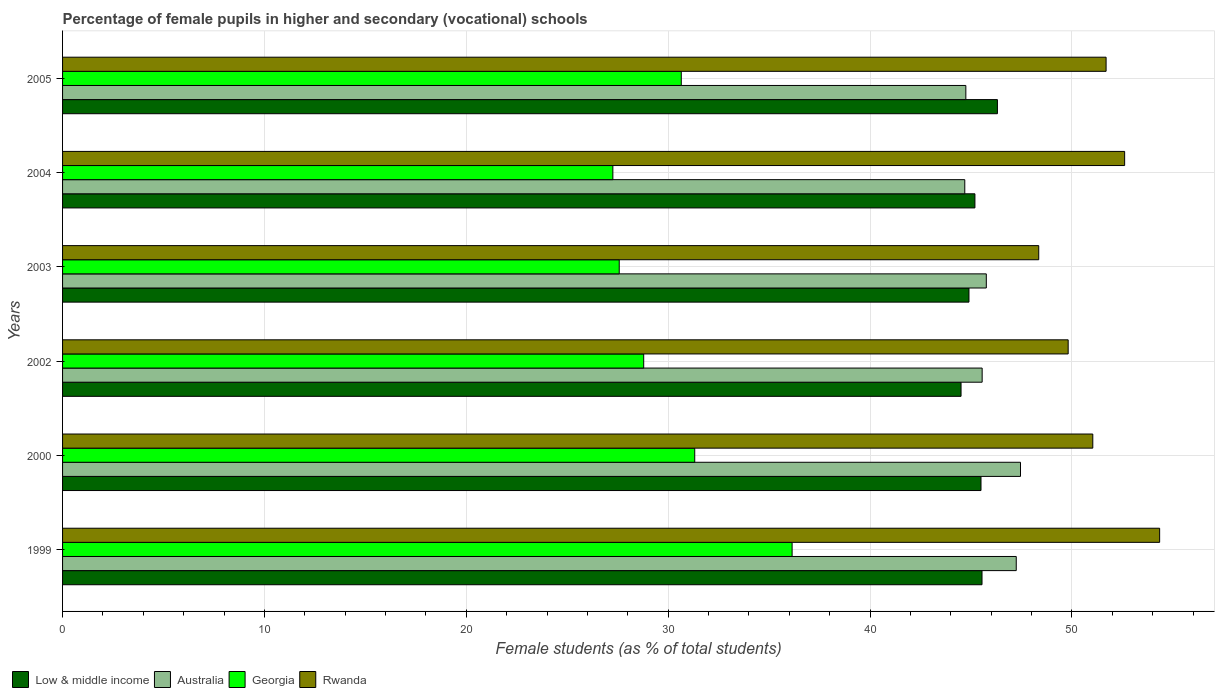How many different coloured bars are there?
Ensure brevity in your answer.  4. What is the label of the 5th group of bars from the top?
Make the answer very short. 2000. What is the percentage of female pupils in higher and secondary schools in Australia in 2005?
Your answer should be very brief. 44.74. Across all years, what is the maximum percentage of female pupils in higher and secondary schools in Low & middle income?
Make the answer very short. 46.31. Across all years, what is the minimum percentage of female pupils in higher and secondary schools in Rwanda?
Your answer should be very brief. 48.35. In which year was the percentage of female pupils in higher and secondary schools in Low & middle income maximum?
Offer a terse response. 2005. In which year was the percentage of female pupils in higher and secondary schools in Australia minimum?
Your answer should be compact. 2004. What is the total percentage of female pupils in higher and secondary schools in Rwanda in the graph?
Provide a short and direct response. 307.85. What is the difference between the percentage of female pupils in higher and secondary schools in Low & middle income in 2002 and that in 2004?
Your answer should be very brief. -0.69. What is the difference between the percentage of female pupils in higher and secondary schools in Low & middle income in 2004 and the percentage of female pupils in higher and secondary schools in Australia in 2000?
Your answer should be very brief. -2.26. What is the average percentage of female pupils in higher and secondary schools in Low & middle income per year?
Ensure brevity in your answer.  45.32. In the year 2002, what is the difference between the percentage of female pupils in higher and secondary schools in Australia and percentage of female pupils in higher and secondary schools in Rwanda?
Provide a short and direct response. -4.26. In how many years, is the percentage of female pupils in higher and secondary schools in Rwanda greater than 38 %?
Make the answer very short. 6. What is the ratio of the percentage of female pupils in higher and secondary schools in Rwanda in 1999 to that in 2004?
Keep it short and to the point. 1.03. Is the difference between the percentage of female pupils in higher and secondary schools in Australia in 2004 and 2005 greater than the difference between the percentage of female pupils in higher and secondary schools in Rwanda in 2004 and 2005?
Ensure brevity in your answer.  No. What is the difference between the highest and the second highest percentage of female pupils in higher and secondary schools in Australia?
Keep it short and to the point. 0.21. What is the difference between the highest and the lowest percentage of female pupils in higher and secondary schools in Georgia?
Your response must be concise. 8.88. Is the sum of the percentage of female pupils in higher and secondary schools in Low & middle income in 2002 and 2003 greater than the maximum percentage of female pupils in higher and secondary schools in Georgia across all years?
Your response must be concise. Yes. Is it the case that in every year, the sum of the percentage of female pupils in higher and secondary schools in Low & middle income and percentage of female pupils in higher and secondary schools in Rwanda is greater than the sum of percentage of female pupils in higher and secondary schools in Australia and percentage of female pupils in higher and secondary schools in Georgia?
Keep it short and to the point. No. What does the 4th bar from the top in 2000 represents?
Offer a terse response. Low & middle income. What does the 1st bar from the bottom in 2003 represents?
Ensure brevity in your answer.  Low & middle income. What is the difference between two consecutive major ticks on the X-axis?
Offer a very short reply. 10. Are the values on the major ticks of X-axis written in scientific E-notation?
Ensure brevity in your answer.  No. How many legend labels are there?
Your response must be concise. 4. What is the title of the graph?
Offer a terse response. Percentage of female pupils in higher and secondary (vocational) schools. Does "Guyana" appear as one of the legend labels in the graph?
Ensure brevity in your answer.  No. What is the label or title of the X-axis?
Offer a very short reply. Female students (as % of total students). What is the Female students (as % of total students) in Low & middle income in 1999?
Your response must be concise. 45.55. What is the Female students (as % of total students) of Australia in 1999?
Your response must be concise. 47.24. What is the Female students (as % of total students) in Georgia in 1999?
Your answer should be very brief. 36.14. What is the Female students (as % of total students) in Rwanda in 1999?
Offer a terse response. 54.34. What is the Female students (as % of total students) of Low & middle income in 2000?
Provide a succinct answer. 45.5. What is the Female students (as % of total students) in Australia in 2000?
Your answer should be compact. 47.45. What is the Female students (as % of total students) in Georgia in 2000?
Provide a succinct answer. 31.31. What is the Female students (as % of total students) in Rwanda in 2000?
Your answer should be compact. 51.03. What is the Female students (as % of total students) of Low & middle income in 2002?
Your response must be concise. 44.51. What is the Female students (as % of total students) in Australia in 2002?
Offer a terse response. 45.55. What is the Female students (as % of total students) in Georgia in 2002?
Give a very brief answer. 28.79. What is the Female students (as % of total students) in Rwanda in 2002?
Keep it short and to the point. 49.81. What is the Female students (as % of total students) of Low & middle income in 2003?
Ensure brevity in your answer.  44.9. What is the Female students (as % of total students) in Australia in 2003?
Give a very brief answer. 45.76. What is the Female students (as % of total students) of Georgia in 2003?
Keep it short and to the point. 27.57. What is the Female students (as % of total students) of Rwanda in 2003?
Your answer should be very brief. 48.35. What is the Female students (as % of total students) of Low & middle income in 2004?
Offer a terse response. 45.19. What is the Female students (as % of total students) of Australia in 2004?
Provide a succinct answer. 44.69. What is the Female students (as % of total students) of Georgia in 2004?
Provide a succinct answer. 27.26. What is the Female students (as % of total students) of Rwanda in 2004?
Provide a short and direct response. 52.61. What is the Female students (as % of total students) of Low & middle income in 2005?
Ensure brevity in your answer.  46.31. What is the Female students (as % of total students) of Australia in 2005?
Keep it short and to the point. 44.74. What is the Female students (as % of total students) in Georgia in 2005?
Keep it short and to the point. 30.65. What is the Female students (as % of total students) in Rwanda in 2005?
Provide a short and direct response. 51.69. Across all years, what is the maximum Female students (as % of total students) in Low & middle income?
Your response must be concise. 46.31. Across all years, what is the maximum Female students (as % of total students) of Australia?
Your response must be concise. 47.45. Across all years, what is the maximum Female students (as % of total students) in Georgia?
Your answer should be compact. 36.14. Across all years, what is the maximum Female students (as % of total students) in Rwanda?
Provide a succinct answer. 54.34. Across all years, what is the minimum Female students (as % of total students) in Low & middle income?
Your answer should be compact. 44.51. Across all years, what is the minimum Female students (as % of total students) in Australia?
Ensure brevity in your answer.  44.69. Across all years, what is the minimum Female students (as % of total students) in Georgia?
Keep it short and to the point. 27.26. Across all years, what is the minimum Female students (as % of total students) of Rwanda?
Offer a very short reply. 48.35. What is the total Female students (as % of total students) of Low & middle income in the graph?
Keep it short and to the point. 271.95. What is the total Female students (as % of total students) in Australia in the graph?
Give a very brief answer. 275.44. What is the total Female students (as % of total students) in Georgia in the graph?
Provide a short and direct response. 181.72. What is the total Female students (as % of total students) of Rwanda in the graph?
Make the answer very short. 307.85. What is the difference between the Female students (as % of total students) in Low & middle income in 1999 and that in 2000?
Provide a short and direct response. 0.05. What is the difference between the Female students (as % of total students) of Australia in 1999 and that in 2000?
Make the answer very short. -0.21. What is the difference between the Female students (as % of total students) of Georgia in 1999 and that in 2000?
Your response must be concise. 4.82. What is the difference between the Female students (as % of total students) in Rwanda in 1999 and that in 2000?
Your answer should be compact. 3.31. What is the difference between the Female students (as % of total students) of Low & middle income in 1999 and that in 2002?
Make the answer very short. 1.04. What is the difference between the Female students (as % of total students) of Australia in 1999 and that in 2002?
Ensure brevity in your answer.  1.69. What is the difference between the Female students (as % of total students) in Georgia in 1999 and that in 2002?
Provide a short and direct response. 7.35. What is the difference between the Female students (as % of total students) of Rwanda in 1999 and that in 2002?
Offer a terse response. 4.53. What is the difference between the Female students (as % of total students) in Low & middle income in 1999 and that in 2003?
Your response must be concise. 0.65. What is the difference between the Female students (as % of total students) in Australia in 1999 and that in 2003?
Your answer should be very brief. 1.48. What is the difference between the Female students (as % of total students) in Georgia in 1999 and that in 2003?
Provide a succinct answer. 8.56. What is the difference between the Female students (as % of total students) in Rwanda in 1999 and that in 2003?
Your response must be concise. 5.99. What is the difference between the Female students (as % of total students) of Low & middle income in 1999 and that in 2004?
Provide a succinct answer. 0.35. What is the difference between the Female students (as % of total students) in Australia in 1999 and that in 2004?
Your answer should be very brief. 2.55. What is the difference between the Female students (as % of total students) in Georgia in 1999 and that in 2004?
Provide a short and direct response. 8.88. What is the difference between the Female students (as % of total students) of Rwanda in 1999 and that in 2004?
Offer a very short reply. 1.73. What is the difference between the Female students (as % of total students) in Low & middle income in 1999 and that in 2005?
Provide a succinct answer. -0.76. What is the difference between the Female students (as % of total students) of Australia in 1999 and that in 2005?
Offer a very short reply. 2.5. What is the difference between the Female students (as % of total students) of Georgia in 1999 and that in 2005?
Keep it short and to the point. 5.49. What is the difference between the Female students (as % of total students) of Rwanda in 1999 and that in 2005?
Ensure brevity in your answer.  2.65. What is the difference between the Female students (as % of total students) in Low & middle income in 2000 and that in 2002?
Ensure brevity in your answer.  0.99. What is the difference between the Female students (as % of total students) in Australia in 2000 and that in 2002?
Make the answer very short. 1.9. What is the difference between the Female students (as % of total students) in Georgia in 2000 and that in 2002?
Provide a succinct answer. 2.53. What is the difference between the Female students (as % of total students) of Rwanda in 2000 and that in 2002?
Provide a short and direct response. 1.22. What is the difference between the Female students (as % of total students) of Low & middle income in 2000 and that in 2003?
Make the answer very short. 0.6. What is the difference between the Female students (as % of total students) of Australia in 2000 and that in 2003?
Provide a succinct answer. 1.69. What is the difference between the Female students (as % of total students) in Georgia in 2000 and that in 2003?
Give a very brief answer. 3.74. What is the difference between the Female students (as % of total students) in Rwanda in 2000 and that in 2003?
Your answer should be very brief. 2.68. What is the difference between the Female students (as % of total students) in Low & middle income in 2000 and that in 2004?
Offer a very short reply. 0.3. What is the difference between the Female students (as % of total students) in Australia in 2000 and that in 2004?
Keep it short and to the point. 2.76. What is the difference between the Female students (as % of total students) of Georgia in 2000 and that in 2004?
Your answer should be compact. 4.06. What is the difference between the Female students (as % of total students) of Rwanda in 2000 and that in 2004?
Make the answer very short. -1.58. What is the difference between the Female students (as % of total students) in Low & middle income in 2000 and that in 2005?
Give a very brief answer. -0.81. What is the difference between the Female students (as % of total students) of Australia in 2000 and that in 2005?
Make the answer very short. 2.71. What is the difference between the Female students (as % of total students) in Georgia in 2000 and that in 2005?
Your response must be concise. 0.67. What is the difference between the Female students (as % of total students) of Rwanda in 2000 and that in 2005?
Give a very brief answer. -0.66. What is the difference between the Female students (as % of total students) in Low & middle income in 2002 and that in 2003?
Give a very brief answer. -0.39. What is the difference between the Female students (as % of total students) in Australia in 2002 and that in 2003?
Provide a short and direct response. -0.21. What is the difference between the Female students (as % of total students) in Georgia in 2002 and that in 2003?
Your response must be concise. 1.21. What is the difference between the Female students (as % of total students) of Rwanda in 2002 and that in 2003?
Ensure brevity in your answer.  1.46. What is the difference between the Female students (as % of total students) in Low & middle income in 2002 and that in 2004?
Give a very brief answer. -0.69. What is the difference between the Female students (as % of total students) in Australia in 2002 and that in 2004?
Ensure brevity in your answer.  0.86. What is the difference between the Female students (as % of total students) of Georgia in 2002 and that in 2004?
Your answer should be compact. 1.53. What is the difference between the Female students (as % of total students) in Rwanda in 2002 and that in 2004?
Offer a very short reply. -2.8. What is the difference between the Female students (as % of total students) in Low & middle income in 2002 and that in 2005?
Provide a short and direct response. -1.8. What is the difference between the Female students (as % of total students) of Australia in 2002 and that in 2005?
Your answer should be compact. 0.81. What is the difference between the Female students (as % of total students) in Georgia in 2002 and that in 2005?
Make the answer very short. -1.86. What is the difference between the Female students (as % of total students) in Rwanda in 2002 and that in 2005?
Give a very brief answer. -1.88. What is the difference between the Female students (as % of total students) in Low & middle income in 2003 and that in 2004?
Offer a very short reply. -0.29. What is the difference between the Female students (as % of total students) in Australia in 2003 and that in 2004?
Your response must be concise. 1.07. What is the difference between the Female students (as % of total students) of Georgia in 2003 and that in 2004?
Give a very brief answer. 0.32. What is the difference between the Female students (as % of total students) in Rwanda in 2003 and that in 2004?
Offer a terse response. -4.26. What is the difference between the Female students (as % of total students) of Low & middle income in 2003 and that in 2005?
Your response must be concise. -1.41. What is the difference between the Female students (as % of total students) of Australia in 2003 and that in 2005?
Offer a terse response. 1.01. What is the difference between the Female students (as % of total students) of Georgia in 2003 and that in 2005?
Provide a short and direct response. -3.07. What is the difference between the Female students (as % of total students) of Rwanda in 2003 and that in 2005?
Offer a terse response. -3.34. What is the difference between the Female students (as % of total students) in Low & middle income in 2004 and that in 2005?
Make the answer very short. -1.11. What is the difference between the Female students (as % of total students) in Australia in 2004 and that in 2005?
Make the answer very short. -0.05. What is the difference between the Female students (as % of total students) in Georgia in 2004 and that in 2005?
Offer a terse response. -3.39. What is the difference between the Female students (as % of total students) in Rwanda in 2004 and that in 2005?
Ensure brevity in your answer.  0.92. What is the difference between the Female students (as % of total students) in Low & middle income in 1999 and the Female students (as % of total students) in Australia in 2000?
Offer a very short reply. -1.91. What is the difference between the Female students (as % of total students) of Low & middle income in 1999 and the Female students (as % of total students) of Georgia in 2000?
Make the answer very short. 14.23. What is the difference between the Female students (as % of total students) in Low & middle income in 1999 and the Female students (as % of total students) in Rwanda in 2000?
Your answer should be very brief. -5.49. What is the difference between the Female students (as % of total students) of Australia in 1999 and the Female students (as % of total students) of Georgia in 2000?
Make the answer very short. 15.93. What is the difference between the Female students (as % of total students) of Australia in 1999 and the Female students (as % of total students) of Rwanda in 2000?
Give a very brief answer. -3.79. What is the difference between the Female students (as % of total students) in Georgia in 1999 and the Female students (as % of total students) in Rwanda in 2000?
Your answer should be very brief. -14.89. What is the difference between the Female students (as % of total students) of Low & middle income in 1999 and the Female students (as % of total students) of Australia in 2002?
Your answer should be very brief. -0.01. What is the difference between the Female students (as % of total students) in Low & middle income in 1999 and the Female students (as % of total students) in Georgia in 2002?
Provide a short and direct response. 16.76. What is the difference between the Female students (as % of total students) in Low & middle income in 1999 and the Female students (as % of total students) in Rwanda in 2002?
Provide a short and direct response. -4.27. What is the difference between the Female students (as % of total students) in Australia in 1999 and the Female students (as % of total students) in Georgia in 2002?
Keep it short and to the point. 18.45. What is the difference between the Female students (as % of total students) in Australia in 1999 and the Female students (as % of total students) in Rwanda in 2002?
Provide a short and direct response. -2.57. What is the difference between the Female students (as % of total students) of Georgia in 1999 and the Female students (as % of total students) of Rwanda in 2002?
Ensure brevity in your answer.  -13.68. What is the difference between the Female students (as % of total students) in Low & middle income in 1999 and the Female students (as % of total students) in Australia in 2003?
Your answer should be very brief. -0.21. What is the difference between the Female students (as % of total students) of Low & middle income in 1999 and the Female students (as % of total students) of Georgia in 2003?
Your response must be concise. 17.97. What is the difference between the Female students (as % of total students) of Low & middle income in 1999 and the Female students (as % of total students) of Rwanda in 2003?
Keep it short and to the point. -2.81. What is the difference between the Female students (as % of total students) in Australia in 1999 and the Female students (as % of total students) in Georgia in 2003?
Keep it short and to the point. 19.67. What is the difference between the Female students (as % of total students) of Australia in 1999 and the Female students (as % of total students) of Rwanda in 2003?
Give a very brief answer. -1.11. What is the difference between the Female students (as % of total students) in Georgia in 1999 and the Female students (as % of total students) in Rwanda in 2003?
Offer a very short reply. -12.22. What is the difference between the Female students (as % of total students) of Low & middle income in 1999 and the Female students (as % of total students) of Australia in 2004?
Your answer should be compact. 0.85. What is the difference between the Female students (as % of total students) of Low & middle income in 1999 and the Female students (as % of total students) of Georgia in 2004?
Provide a short and direct response. 18.29. What is the difference between the Female students (as % of total students) of Low & middle income in 1999 and the Female students (as % of total students) of Rwanda in 2004?
Offer a terse response. -7.07. What is the difference between the Female students (as % of total students) of Australia in 1999 and the Female students (as % of total students) of Georgia in 2004?
Offer a terse response. 19.98. What is the difference between the Female students (as % of total students) in Australia in 1999 and the Female students (as % of total students) in Rwanda in 2004?
Offer a very short reply. -5.37. What is the difference between the Female students (as % of total students) in Georgia in 1999 and the Female students (as % of total students) in Rwanda in 2004?
Offer a very short reply. -16.47. What is the difference between the Female students (as % of total students) of Low & middle income in 1999 and the Female students (as % of total students) of Australia in 2005?
Give a very brief answer. 0.8. What is the difference between the Female students (as % of total students) of Low & middle income in 1999 and the Female students (as % of total students) of Georgia in 2005?
Your answer should be very brief. 14.9. What is the difference between the Female students (as % of total students) in Low & middle income in 1999 and the Female students (as % of total students) in Rwanda in 2005?
Ensure brevity in your answer.  -6.15. What is the difference between the Female students (as % of total students) in Australia in 1999 and the Female students (as % of total students) in Georgia in 2005?
Your answer should be compact. 16.59. What is the difference between the Female students (as % of total students) in Australia in 1999 and the Female students (as % of total students) in Rwanda in 2005?
Your answer should be compact. -4.45. What is the difference between the Female students (as % of total students) of Georgia in 1999 and the Female students (as % of total students) of Rwanda in 2005?
Your answer should be very brief. -15.55. What is the difference between the Female students (as % of total students) in Low & middle income in 2000 and the Female students (as % of total students) in Australia in 2002?
Keep it short and to the point. -0.06. What is the difference between the Female students (as % of total students) in Low & middle income in 2000 and the Female students (as % of total students) in Georgia in 2002?
Provide a short and direct response. 16.71. What is the difference between the Female students (as % of total students) of Low & middle income in 2000 and the Female students (as % of total students) of Rwanda in 2002?
Provide a short and direct response. -4.32. What is the difference between the Female students (as % of total students) in Australia in 2000 and the Female students (as % of total students) in Georgia in 2002?
Provide a succinct answer. 18.66. What is the difference between the Female students (as % of total students) in Australia in 2000 and the Female students (as % of total students) in Rwanda in 2002?
Your response must be concise. -2.36. What is the difference between the Female students (as % of total students) of Georgia in 2000 and the Female students (as % of total students) of Rwanda in 2002?
Your answer should be compact. -18.5. What is the difference between the Female students (as % of total students) of Low & middle income in 2000 and the Female students (as % of total students) of Australia in 2003?
Offer a very short reply. -0.26. What is the difference between the Female students (as % of total students) of Low & middle income in 2000 and the Female students (as % of total students) of Georgia in 2003?
Ensure brevity in your answer.  17.92. What is the difference between the Female students (as % of total students) of Low & middle income in 2000 and the Female students (as % of total students) of Rwanda in 2003?
Ensure brevity in your answer.  -2.86. What is the difference between the Female students (as % of total students) of Australia in 2000 and the Female students (as % of total students) of Georgia in 2003?
Keep it short and to the point. 19.88. What is the difference between the Female students (as % of total students) of Australia in 2000 and the Female students (as % of total students) of Rwanda in 2003?
Offer a very short reply. -0.9. What is the difference between the Female students (as % of total students) of Georgia in 2000 and the Female students (as % of total students) of Rwanda in 2003?
Your answer should be very brief. -17.04. What is the difference between the Female students (as % of total students) in Low & middle income in 2000 and the Female students (as % of total students) in Australia in 2004?
Provide a succinct answer. 0.8. What is the difference between the Female students (as % of total students) in Low & middle income in 2000 and the Female students (as % of total students) in Georgia in 2004?
Offer a very short reply. 18.24. What is the difference between the Female students (as % of total students) in Low & middle income in 2000 and the Female students (as % of total students) in Rwanda in 2004?
Ensure brevity in your answer.  -7.11. What is the difference between the Female students (as % of total students) of Australia in 2000 and the Female students (as % of total students) of Georgia in 2004?
Provide a succinct answer. 20.19. What is the difference between the Female students (as % of total students) of Australia in 2000 and the Female students (as % of total students) of Rwanda in 2004?
Provide a short and direct response. -5.16. What is the difference between the Female students (as % of total students) in Georgia in 2000 and the Female students (as % of total students) in Rwanda in 2004?
Offer a very short reply. -21.3. What is the difference between the Female students (as % of total students) in Low & middle income in 2000 and the Female students (as % of total students) in Australia in 2005?
Offer a terse response. 0.75. What is the difference between the Female students (as % of total students) of Low & middle income in 2000 and the Female students (as % of total students) of Georgia in 2005?
Your response must be concise. 14.85. What is the difference between the Female students (as % of total students) in Low & middle income in 2000 and the Female students (as % of total students) in Rwanda in 2005?
Provide a succinct answer. -6.2. What is the difference between the Female students (as % of total students) of Australia in 2000 and the Female students (as % of total students) of Georgia in 2005?
Your answer should be very brief. 16.8. What is the difference between the Female students (as % of total students) of Australia in 2000 and the Female students (as % of total students) of Rwanda in 2005?
Keep it short and to the point. -4.24. What is the difference between the Female students (as % of total students) in Georgia in 2000 and the Female students (as % of total students) in Rwanda in 2005?
Give a very brief answer. -20.38. What is the difference between the Female students (as % of total students) in Low & middle income in 2002 and the Female students (as % of total students) in Australia in 2003?
Make the answer very short. -1.25. What is the difference between the Female students (as % of total students) of Low & middle income in 2002 and the Female students (as % of total students) of Georgia in 2003?
Your response must be concise. 16.93. What is the difference between the Female students (as % of total students) of Low & middle income in 2002 and the Female students (as % of total students) of Rwanda in 2003?
Make the answer very short. -3.85. What is the difference between the Female students (as % of total students) of Australia in 2002 and the Female students (as % of total students) of Georgia in 2003?
Give a very brief answer. 17.98. What is the difference between the Female students (as % of total students) of Australia in 2002 and the Female students (as % of total students) of Rwanda in 2003?
Ensure brevity in your answer.  -2.8. What is the difference between the Female students (as % of total students) in Georgia in 2002 and the Female students (as % of total students) in Rwanda in 2003?
Give a very brief answer. -19.57. What is the difference between the Female students (as % of total students) of Low & middle income in 2002 and the Female students (as % of total students) of Australia in 2004?
Make the answer very short. -0.18. What is the difference between the Female students (as % of total students) of Low & middle income in 2002 and the Female students (as % of total students) of Georgia in 2004?
Your response must be concise. 17.25. What is the difference between the Female students (as % of total students) in Low & middle income in 2002 and the Female students (as % of total students) in Rwanda in 2004?
Your answer should be very brief. -8.1. What is the difference between the Female students (as % of total students) in Australia in 2002 and the Female students (as % of total students) in Georgia in 2004?
Keep it short and to the point. 18.29. What is the difference between the Female students (as % of total students) of Australia in 2002 and the Female students (as % of total students) of Rwanda in 2004?
Give a very brief answer. -7.06. What is the difference between the Female students (as % of total students) in Georgia in 2002 and the Female students (as % of total students) in Rwanda in 2004?
Give a very brief answer. -23.82. What is the difference between the Female students (as % of total students) of Low & middle income in 2002 and the Female students (as % of total students) of Australia in 2005?
Your answer should be compact. -0.24. What is the difference between the Female students (as % of total students) in Low & middle income in 2002 and the Female students (as % of total students) in Georgia in 2005?
Make the answer very short. 13.86. What is the difference between the Female students (as % of total students) in Low & middle income in 2002 and the Female students (as % of total students) in Rwanda in 2005?
Offer a very short reply. -7.18. What is the difference between the Female students (as % of total students) of Australia in 2002 and the Female students (as % of total students) of Georgia in 2005?
Keep it short and to the point. 14.9. What is the difference between the Female students (as % of total students) in Australia in 2002 and the Female students (as % of total students) in Rwanda in 2005?
Offer a very short reply. -6.14. What is the difference between the Female students (as % of total students) of Georgia in 2002 and the Female students (as % of total students) of Rwanda in 2005?
Make the answer very short. -22.9. What is the difference between the Female students (as % of total students) in Low & middle income in 2003 and the Female students (as % of total students) in Australia in 2004?
Make the answer very short. 0.21. What is the difference between the Female students (as % of total students) in Low & middle income in 2003 and the Female students (as % of total students) in Georgia in 2004?
Make the answer very short. 17.64. What is the difference between the Female students (as % of total students) of Low & middle income in 2003 and the Female students (as % of total students) of Rwanda in 2004?
Offer a terse response. -7.71. What is the difference between the Female students (as % of total students) in Australia in 2003 and the Female students (as % of total students) in Georgia in 2004?
Your answer should be compact. 18.5. What is the difference between the Female students (as % of total students) in Australia in 2003 and the Female students (as % of total students) in Rwanda in 2004?
Your answer should be compact. -6.85. What is the difference between the Female students (as % of total students) of Georgia in 2003 and the Female students (as % of total students) of Rwanda in 2004?
Provide a short and direct response. -25.04. What is the difference between the Female students (as % of total students) in Low & middle income in 2003 and the Female students (as % of total students) in Australia in 2005?
Ensure brevity in your answer.  0.15. What is the difference between the Female students (as % of total students) in Low & middle income in 2003 and the Female students (as % of total students) in Georgia in 2005?
Your answer should be very brief. 14.25. What is the difference between the Female students (as % of total students) of Low & middle income in 2003 and the Female students (as % of total students) of Rwanda in 2005?
Ensure brevity in your answer.  -6.79. What is the difference between the Female students (as % of total students) of Australia in 2003 and the Female students (as % of total students) of Georgia in 2005?
Give a very brief answer. 15.11. What is the difference between the Female students (as % of total students) in Australia in 2003 and the Female students (as % of total students) in Rwanda in 2005?
Your response must be concise. -5.93. What is the difference between the Female students (as % of total students) in Georgia in 2003 and the Female students (as % of total students) in Rwanda in 2005?
Offer a very short reply. -24.12. What is the difference between the Female students (as % of total students) of Low & middle income in 2004 and the Female students (as % of total students) of Australia in 2005?
Provide a succinct answer. 0.45. What is the difference between the Female students (as % of total students) in Low & middle income in 2004 and the Female students (as % of total students) in Georgia in 2005?
Ensure brevity in your answer.  14.55. What is the difference between the Female students (as % of total students) in Low & middle income in 2004 and the Female students (as % of total students) in Rwanda in 2005?
Ensure brevity in your answer.  -6.5. What is the difference between the Female students (as % of total students) in Australia in 2004 and the Female students (as % of total students) in Georgia in 2005?
Offer a terse response. 14.04. What is the difference between the Female students (as % of total students) in Australia in 2004 and the Female students (as % of total students) in Rwanda in 2005?
Your answer should be very brief. -7. What is the difference between the Female students (as % of total students) of Georgia in 2004 and the Female students (as % of total students) of Rwanda in 2005?
Ensure brevity in your answer.  -24.43. What is the average Female students (as % of total students) of Low & middle income per year?
Offer a very short reply. 45.32. What is the average Female students (as % of total students) in Australia per year?
Your answer should be compact. 45.91. What is the average Female students (as % of total students) of Georgia per year?
Ensure brevity in your answer.  30.29. What is the average Female students (as % of total students) of Rwanda per year?
Keep it short and to the point. 51.31. In the year 1999, what is the difference between the Female students (as % of total students) of Low & middle income and Female students (as % of total students) of Australia?
Your response must be concise. -1.7. In the year 1999, what is the difference between the Female students (as % of total students) in Low & middle income and Female students (as % of total students) in Georgia?
Ensure brevity in your answer.  9.41. In the year 1999, what is the difference between the Female students (as % of total students) of Low & middle income and Female students (as % of total students) of Rwanda?
Your answer should be compact. -8.8. In the year 1999, what is the difference between the Female students (as % of total students) in Australia and Female students (as % of total students) in Georgia?
Provide a short and direct response. 11.1. In the year 1999, what is the difference between the Female students (as % of total students) of Australia and Female students (as % of total students) of Rwanda?
Your answer should be very brief. -7.1. In the year 1999, what is the difference between the Female students (as % of total students) of Georgia and Female students (as % of total students) of Rwanda?
Offer a very short reply. -18.21. In the year 2000, what is the difference between the Female students (as % of total students) of Low & middle income and Female students (as % of total students) of Australia?
Your answer should be very brief. -1.96. In the year 2000, what is the difference between the Female students (as % of total students) in Low & middle income and Female students (as % of total students) in Georgia?
Offer a very short reply. 14.18. In the year 2000, what is the difference between the Female students (as % of total students) of Low & middle income and Female students (as % of total students) of Rwanda?
Make the answer very short. -5.54. In the year 2000, what is the difference between the Female students (as % of total students) of Australia and Female students (as % of total students) of Georgia?
Your answer should be compact. 16.14. In the year 2000, what is the difference between the Female students (as % of total students) of Australia and Female students (as % of total students) of Rwanda?
Your answer should be compact. -3.58. In the year 2000, what is the difference between the Female students (as % of total students) in Georgia and Female students (as % of total students) in Rwanda?
Your answer should be very brief. -19.72. In the year 2002, what is the difference between the Female students (as % of total students) of Low & middle income and Female students (as % of total students) of Australia?
Make the answer very short. -1.05. In the year 2002, what is the difference between the Female students (as % of total students) in Low & middle income and Female students (as % of total students) in Georgia?
Ensure brevity in your answer.  15.72. In the year 2002, what is the difference between the Female students (as % of total students) of Low & middle income and Female students (as % of total students) of Rwanda?
Offer a very short reply. -5.31. In the year 2002, what is the difference between the Female students (as % of total students) of Australia and Female students (as % of total students) of Georgia?
Make the answer very short. 16.77. In the year 2002, what is the difference between the Female students (as % of total students) of Australia and Female students (as % of total students) of Rwanda?
Provide a succinct answer. -4.26. In the year 2002, what is the difference between the Female students (as % of total students) in Georgia and Female students (as % of total students) in Rwanda?
Offer a terse response. -21.03. In the year 2003, what is the difference between the Female students (as % of total students) in Low & middle income and Female students (as % of total students) in Australia?
Offer a very short reply. -0.86. In the year 2003, what is the difference between the Female students (as % of total students) of Low & middle income and Female students (as % of total students) of Georgia?
Provide a succinct answer. 17.32. In the year 2003, what is the difference between the Female students (as % of total students) in Low & middle income and Female students (as % of total students) in Rwanda?
Your answer should be very brief. -3.46. In the year 2003, what is the difference between the Female students (as % of total students) in Australia and Female students (as % of total students) in Georgia?
Provide a short and direct response. 18.18. In the year 2003, what is the difference between the Female students (as % of total students) in Australia and Female students (as % of total students) in Rwanda?
Offer a terse response. -2.6. In the year 2003, what is the difference between the Female students (as % of total students) in Georgia and Female students (as % of total students) in Rwanda?
Keep it short and to the point. -20.78. In the year 2004, what is the difference between the Female students (as % of total students) of Low & middle income and Female students (as % of total students) of Australia?
Your answer should be compact. 0.5. In the year 2004, what is the difference between the Female students (as % of total students) in Low & middle income and Female students (as % of total students) in Georgia?
Offer a terse response. 17.93. In the year 2004, what is the difference between the Female students (as % of total students) of Low & middle income and Female students (as % of total students) of Rwanda?
Your answer should be compact. -7.42. In the year 2004, what is the difference between the Female students (as % of total students) of Australia and Female students (as % of total students) of Georgia?
Your answer should be very brief. 17.43. In the year 2004, what is the difference between the Female students (as % of total students) of Australia and Female students (as % of total students) of Rwanda?
Offer a terse response. -7.92. In the year 2004, what is the difference between the Female students (as % of total students) in Georgia and Female students (as % of total students) in Rwanda?
Provide a succinct answer. -25.35. In the year 2005, what is the difference between the Female students (as % of total students) of Low & middle income and Female students (as % of total students) of Australia?
Provide a short and direct response. 1.56. In the year 2005, what is the difference between the Female students (as % of total students) in Low & middle income and Female students (as % of total students) in Georgia?
Give a very brief answer. 15.66. In the year 2005, what is the difference between the Female students (as % of total students) in Low & middle income and Female students (as % of total students) in Rwanda?
Keep it short and to the point. -5.38. In the year 2005, what is the difference between the Female students (as % of total students) in Australia and Female students (as % of total students) in Georgia?
Keep it short and to the point. 14.1. In the year 2005, what is the difference between the Female students (as % of total students) of Australia and Female students (as % of total students) of Rwanda?
Give a very brief answer. -6.95. In the year 2005, what is the difference between the Female students (as % of total students) in Georgia and Female students (as % of total students) in Rwanda?
Your response must be concise. -21.04. What is the ratio of the Female students (as % of total students) of Low & middle income in 1999 to that in 2000?
Ensure brevity in your answer.  1. What is the ratio of the Female students (as % of total students) of Georgia in 1999 to that in 2000?
Offer a very short reply. 1.15. What is the ratio of the Female students (as % of total students) in Rwanda in 1999 to that in 2000?
Provide a short and direct response. 1.06. What is the ratio of the Female students (as % of total students) in Low & middle income in 1999 to that in 2002?
Offer a very short reply. 1.02. What is the ratio of the Female students (as % of total students) in Australia in 1999 to that in 2002?
Keep it short and to the point. 1.04. What is the ratio of the Female students (as % of total students) in Georgia in 1999 to that in 2002?
Make the answer very short. 1.26. What is the ratio of the Female students (as % of total students) in Rwanda in 1999 to that in 2002?
Provide a short and direct response. 1.09. What is the ratio of the Female students (as % of total students) in Low & middle income in 1999 to that in 2003?
Give a very brief answer. 1.01. What is the ratio of the Female students (as % of total students) of Australia in 1999 to that in 2003?
Your answer should be very brief. 1.03. What is the ratio of the Female students (as % of total students) of Georgia in 1999 to that in 2003?
Provide a succinct answer. 1.31. What is the ratio of the Female students (as % of total students) in Rwanda in 1999 to that in 2003?
Provide a succinct answer. 1.12. What is the ratio of the Female students (as % of total students) in Australia in 1999 to that in 2004?
Provide a short and direct response. 1.06. What is the ratio of the Female students (as % of total students) in Georgia in 1999 to that in 2004?
Keep it short and to the point. 1.33. What is the ratio of the Female students (as % of total students) of Rwanda in 1999 to that in 2004?
Your answer should be very brief. 1.03. What is the ratio of the Female students (as % of total students) in Low & middle income in 1999 to that in 2005?
Provide a short and direct response. 0.98. What is the ratio of the Female students (as % of total students) in Australia in 1999 to that in 2005?
Give a very brief answer. 1.06. What is the ratio of the Female students (as % of total students) of Georgia in 1999 to that in 2005?
Keep it short and to the point. 1.18. What is the ratio of the Female students (as % of total students) of Rwanda in 1999 to that in 2005?
Ensure brevity in your answer.  1.05. What is the ratio of the Female students (as % of total students) of Low & middle income in 2000 to that in 2002?
Keep it short and to the point. 1.02. What is the ratio of the Female students (as % of total students) of Australia in 2000 to that in 2002?
Offer a terse response. 1.04. What is the ratio of the Female students (as % of total students) in Georgia in 2000 to that in 2002?
Offer a terse response. 1.09. What is the ratio of the Female students (as % of total students) in Rwanda in 2000 to that in 2002?
Your answer should be very brief. 1.02. What is the ratio of the Female students (as % of total students) in Low & middle income in 2000 to that in 2003?
Your response must be concise. 1.01. What is the ratio of the Female students (as % of total students) of Georgia in 2000 to that in 2003?
Your answer should be very brief. 1.14. What is the ratio of the Female students (as % of total students) in Rwanda in 2000 to that in 2003?
Offer a very short reply. 1.06. What is the ratio of the Female students (as % of total students) of Australia in 2000 to that in 2004?
Offer a very short reply. 1.06. What is the ratio of the Female students (as % of total students) of Georgia in 2000 to that in 2004?
Give a very brief answer. 1.15. What is the ratio of the Female students (as % of total students) of Rwanda in 2000 to that in 2004?
Your answer should be compact. 0.97. What is the ratio of the Female students (as % of total students) in Low & middle income in 2000 to that in 2005?
Your response must be concise. 0.98. What is the ratio of the Female students (as % of total students) in Australia in 2000 to that in 2005?
Keep it short and to the point. 1.06. What is the ratio of the Female students (as % of total students) in Georgia in 2000 to that in 2005?
Your answer should be very brief. 1.02. What is the ratio of the Female students (as % of total students) of Rwanda in 2000 to that in 2005?
Offer a very short reply. 0.99. What is the ratio of the Female students (as % of total students) in Georgia in 2002 to that in 2003?
Make the answer very short. 1.04. What is the ratio of the Female students (as % of total students) in Rwanda in 2002 to that in 2003?
Ensure brevity in your answer.  1.03. What is the ratio of the Female students (as % of total students) of Low & middle income in 2002 to that in 2004?
Your answer should be compact. 0.98. What is the ratio of the Female students (as % of total students) of Australia in 2002 to that in 2004?
Make the answer very short. 1.02. What is the ratio of the Female students (as % of total students) of Georgia in 2002 to that in 2004?
Ensure brevity in your answer.  1.06. What is the ratio of the Female students (as % of total students) of Rwanda in 2002 to that in 2004?
Your answer should be very brief. 0.95. What is the ratio of the Female students (as % of total students) in Low & middle income in 2002 to that in 2005?
Your answer should be compact. 0.96. What is the ratio of the Female students (as % of total students) in Australia in 2002 to that in 2005?
Provide a short and direct response. 1.02. What is the ratio of the Female students (as % of total students) in Georgia in 2002 to that in 2005?
Give a very brief answer. 0.94. What is the ratio of the Female students (as % of total students) in Rwanda in 2002 to that in 2005?
Provide a short and direct response. 0.96. What is the ratio of the Female students (as % of total students) of Low & middle income in 2003 to that in 2004?
Offer a very short reply. 0.99. What is the ratio of the Female students (as % of total students) in Australia in 2003 to that in 2004?
Keep it short and to the point. 1.02. What is the ratio of the Female students (as % of total students) of Georgia in 2003 to that in 2004?
Provide a succinct answer. 1.01. What is the ratio of the Female students (as % of total students) of Rwanda in 2003 to that in 2004?
Make the answer very short. 0.92. What is the ratio of the Female students (as % of total students) of Low & middle income in 2003 to that in 2005?
Your answer should be very brief. 0.97. What is the ratio of the Female students (as % of total students) in Australia in 2003 to that in 2005?
Your answer should be compact. 1.02. What is the ratio of the Female students (as % of total students) of Georgia in 2003 to that in 2005?
Offer a terse response. 0.9. What is the ratio of the Female students (as % of total students) of Rwanda in 2003 to that in 2005?
Ensure brevity in your answer.  0.94. What is the ratio of the Female students (as % of total students) of Low & middle income in 2004 to that in 2005?
Make the answer very short. 0.98. What is the ratio of the Female students (as % of total students) in Australia in 2004 to that in 2005?
Offer a terse response. 1. What is the ratio of the Female students (as % of total students) in Georgia in 2004 to that in 2005?
Offer a very short reply. 0.89. What is the ratio of the Female students (as % of total students) in Rwanda in 2004 to that in 2005?
Provide a short and direct response. 1.02. What is the difference between the highest and the second highest Female students (as % of total students) in Low & middle income?
Your answer should be compact. 0.76. What is the difference between the highest and the second highest Female students (as % of total students) in Australia?
Offer a terse response. 0.21. What is the difference between the highest and the second highest Female students (as % of total students) in Georgia?
Give a very brief answer. 4.82. What is the difference between the highest and the second highest Female students (as % of total students) in Rwanda?
Provide a succinct answer. 1.73. What is the difference between the highest and the lowest Female students (as % of total students) in Low & middle income?
Your response must be concise. 1.8. What is the difference between the highest and the lowest Female students (as % of total students) of Australia?
Your response must be concise. 2.76. What is the difference between the highest and the lowest Female students (as % of total students) of Georgia?
Your response must be concise. 8.88. What is the difference between the highest and the lowest Female students (as % of total students) in Rwanda?
Keep it short and to the point. 5.99. 